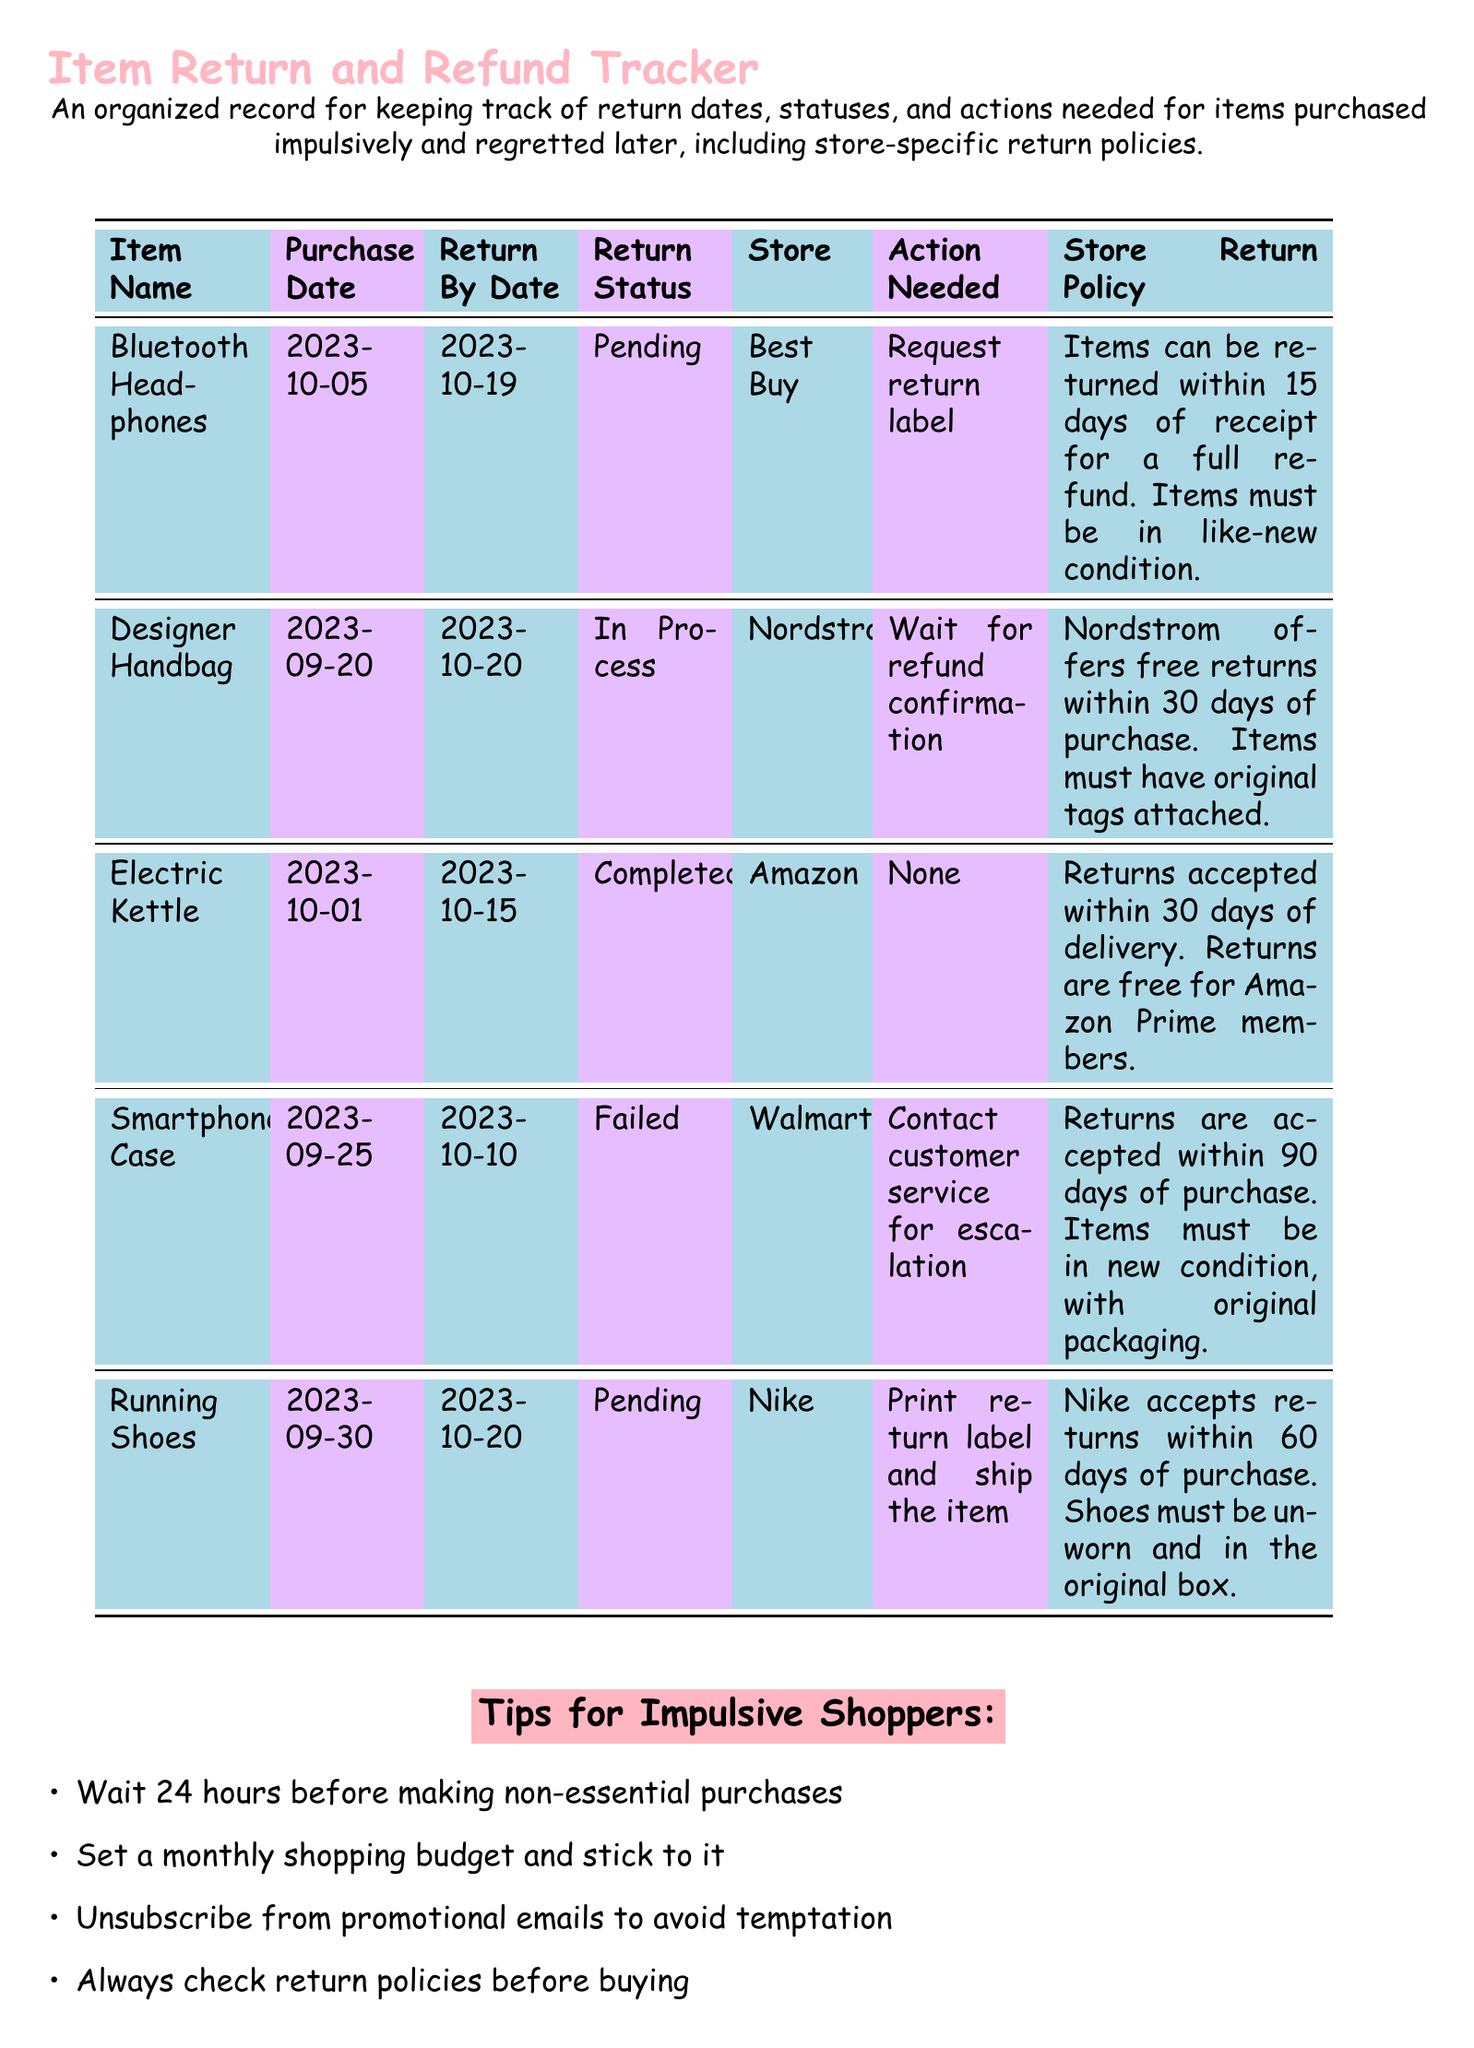What is the return status of the Bluetooth Headphones? This is found in the "Return Status" column for the listed item, which reads "Pending."
Answer: Pending When is the return by date for the Designer Handbag? The return by date for this item is specified in the "Return By Date" column, which states "2023-10-20."
Answer: 2023-10-20 What action is needed for the Running Shoes? The required action for this item is detailed under "Action Needed," which states to "Print return label and ship the item."
Answer: Print return label and ship the item How many days does Nordstrom allow for returns? This is mentioned in the store return policy for Nordstrom, which states "30 days of purchase."
Answer: 30 days Which item has a completed return status? The completed status can be found in the "Return Status" column, and the item listed as such is "Electric Kettle."
Answer: Electric Kettle What is the store return policy for Walmart? The return policy is described in the "Store Return Policy" column, indicating that items can be returned "within 90 days of purchase."
Answer: within 90 days of purchase What is the purchase date for the Smartphone Case? This information is located in the "Purchase Date" column where the date listed is "2023-09-25."
Answer: 2023-09-25 What color is used for the document's section headings? The color used for the headings is specified in the document setup as "shoppink."
Answer: shoppink What is a tip for impulsive shoppers? Tips can be found in the itemized list, focusing on shopping behaviors. One example is to "Wait 24 hours before making non-essential purchases."
Answer: Wait 24 hours before making non-essential purchases 